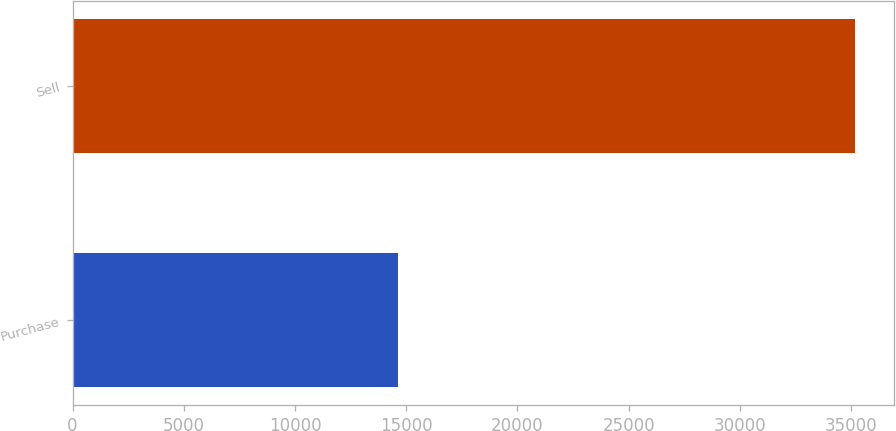Convert chart to OTSL. <chart><loc_0><loc_0><loc_500><loc_500><bar_chart><fcel>Purchase<fcel>Sell<nl><fcel>14641<fcel>35178<nl></chart> 